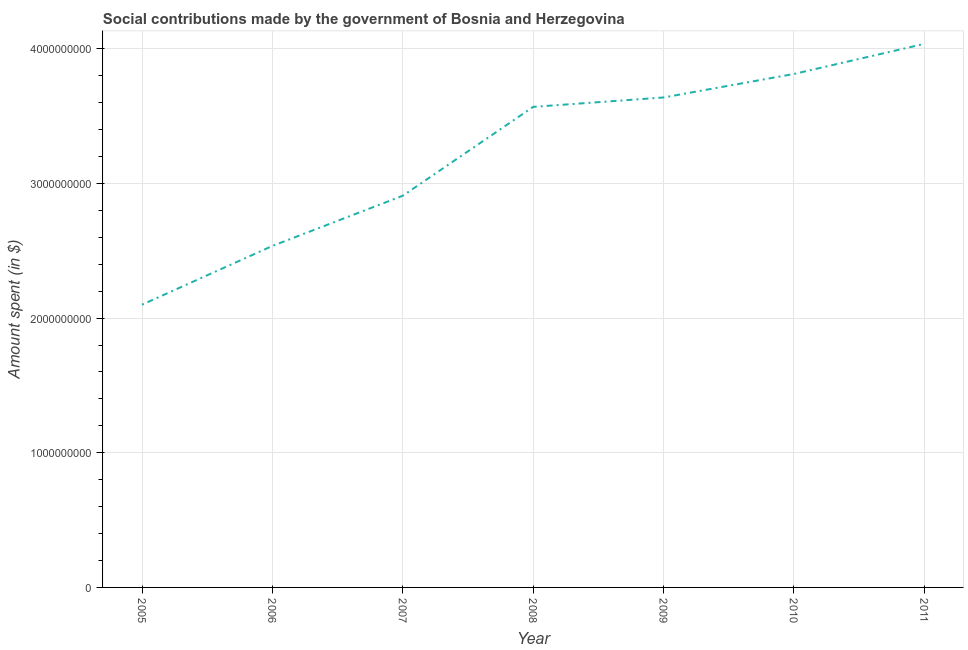What is the amount spent in making social contributions in 2010?
Your answer should be very brief. 3.81e+09. Across all years, what is the maximum amount spent in making social contributions?
Offer a terse response. 4.04e+09. Across all years, what is the minimum amount spent in making social contributions?
Offer a terse response. 2.10e+09. In which year was the amount spent in making social contributions maximum?
Offer a terse response. 2011. In which year was the amount spent in making social contributions minimum?
Ensure brevity in your answer.  2005. What is the sum of the amount spent in making social contributions?
Your response must be concise. 2.26e+1. What is the difference between the amount spent in making social contributions in 2006 and 2009?
Make the answer very short. -1.10e+09. What is the average amount spent in making social contributions per year?
Give a very brief answer. 3.23e+09. What is the median amount spent in making social contributions?
Ensure brevity in your answer.  3.57e+09. Do a majority of the years between 2009 and 2011 (inclusive) have amount spent in making social contributions greater than 400000000 $?
Provide a short and direct response. Yes. What is the ratio of the amount spent in making social contributions in 2006 to that in 2007?
Your answer should be very brief. 0.87. Is the difference between the amount spent in making social contributions in 2005 and 2011 greater than the difference between any two years?
Your response must be concise. Yes. What is the difference between the highest and the second highest amount spent in making social contributions?
Offer a terse response. 2.23e+08. Is the sum of the amount spent in making social contributions in 2007 and 2008 greater than the maximum amount spent in making social contributions across all years?
Give a very brief answer. Yes. What is the difference between the highest and the lowest amount spent in making social contributions?
Offer a very short reply. 1.94e+09. In how many years, is the amount spent in making social contributions greater than the average amount spent in making social contributions taken over all years?
Your answer should be compact. 4. Does the amount spent in making social contributions monotonically increase over the years?
Provide a short and direct response. Yes. How many lines are there?
Your answer should be compact. 1. What is the difference between two consecutive major ticks on the Y-axis?
Provide a short and direct response. 1.00e+09. Does the graph contain any zero values?
Your response must be concise. No. Does the graph contain grids?
Keep it short and to the point. Yes. What is the title of the graph?
Your answer should be compact. Social contributions made by the government of Bosnia and Herzegovina. What is the label or title of the X-axis?
Offer a very short reply. Year. What is the label or title of the Y-axis?
Keep it short and to the point. Amount spent (in $). What is the Amount spent (in $) of 2005?
Your answer should be compact. 2.10e+09. What is the Amount spent (in $) of 2006?
Your response must be concise. 2.54e+09. What is the Amount spent (in $) in 2007?
Give a very brief answer. 2.91e+09. What is the Amount spent (in $) of 2008?
Your answer should be compact. 3.57e+09. What is the Amount spent (in $) of 2009?
Your answer should be very brief. 3.64e+09. What is the Amount spent (in $) in 2010?
Keep it short and to the point. 3.81e+09. What is the Amount spent (in $) in 2011?
Provide a short and direct response. 4.04e+09. What is the difference between the Amount spent (in $) in 2005 and 2006?
Keep it short and to the point. -4.36e+08. What is the difference between the Amount spent (in $) in 2005 and 2007?
Provide a short and direct response. -8.09e+08. What is the difference between the Amount spent (in $) in 2005 and 2008?
Ensure brevity in your answer.  -1.47e+09. What is the difference between the Amount spent (in $) in 2005 and 2009?
Your answer should be very brief. -1.54e+09. What is the difference between the Amount spent (in $) in 2005 and 2010?
Ensure brevity in your answer.  -1.71e+09. What is the difference between the Amount spent (in $) in 2005 and 2011?
Offer a terse response. -1.94e+09. What is the difference between the Amount spent (in $) in 2006 and 2007?
Give a very brief answer. -3.73e+08. What is the difference between the Amount spent (in $) in 2006 and 2008?
Give a very brief answer. -1.03e+09. What is the difference between the Amount spent (in $) in 2006 and 2009?
Ensure brevity in your answer.  -1.10e+09. What is the difference between the Amount spent (in $) in 2006 and 2010?
Ensure brevity in your answer.  -1.28e+09. What is the difference between the Amount spent (in $) in 2006 and 2011?
Your response must be concise. -1.50e+09. What is the difference between the Amount spent (in $) in 2007 and 2008?
Your answer should be very brief. -6.60e+08. What is the difference between the Amount spent (in $) in 2007 and 2009?
Give a very brief answer. -7.30e+08. What is the difference between the Amount spent (in $) in 2007 and 2010?
Ensure brevity in your answer.  -9.04e+08. What is the difference between the Amount spent (in $) in 2007 and 2011?
Make the answer very short. -1.13e+09. What is the difference between the Amount spent (in $) in 2008 and 2009?
Your answer should be very brief. -6.99e+07. What is the difference between the Amount spent (in $) in 2008 and 2010?
Offer a very short reply. -2.44e+08. What is the difference between the Amount spent (in $) in 2008 and 2011?
Your answer should be compact. -4.68e+08. What is the difference between the Amount spent (in $) in 2009 and 2010?
Offer a very short reply. -1.75e+08. What is the difference between the Amount spent (in $) in 2009 and 2011?
Keep it short and to the point. -3.98e+08. What is the difference between the Amount spent (in $) in 2010 and 2011?
Offer a very short reply. -2.23e+08. What is the ratio of the Amount spent (in $) in 2005 to that in 2006?
Offer a very short reply. 0.83. What is the ratio of the Amount spent (in $) in 2005 to that in 2007?
Offer a terse response. 0.72. What is the ratio of the Amount spent (in $) in 2005 to that in 2008?
Offer a terse response. 0.59. What is the ratio of the Amount spent (in $) in 2005 to that in 2009?
Offer a very short reply. 0.58. What is the ratio of the Amount spent (in $) in 2005 to that in 2010?
Ensure brevity in your answer.  0.55. What is the ratio of the Amount spent (in $) in 2005 to that in 2011?
Your response must be concise. 0.52. What is the ratio of the Amount spent (in $) in 2006 to that in 2007?
Give a very brief answer. 0.87. What is the ratio of the Amount spent (in $) in 2006 to that in 2008?
Your answer should be compact. 0.71. What is the ratio of the Amount spent (in $) in 2006 to that in 2009?
Give a very brief answer. 0.7. What is the ratio of the Amount spent (in $) in 2006 to that in 2010?
Your response must be concise. 0.67. What is the ratio of the Amount spent (in $) in 2006 to that in 2011?
Your response must be concise. 0.63. What is the ratio of the Amount spent (in $) in 2007 to that in 2008?
Ensure brevity in your answer.  0.81. What is the ratio of the Amount spent (in $) in 2007 to that in 2009?
Ensure brevity in your answer.  0.8. What is the ratio of the Amount spent (in $) in 2007 to that in 2010?
Give a very brief answer. 0.76. What is the ratio of the Amount spent (in $) in 2007 to that in 2011?
Give a very brief answer. 0.72. What is the ratio of the Amount spent (in $) in 2008 to that in 2010?
Make the answer very short. 0.94. What is the ratio of the Amount spent (in $) in 2008 to that in 2011?
Ensure brevity in your answer.  0.88. What is the ratio of the Amount spent (in $) in 2009 to that in 2010?
Give a very brief answer. 0.95. What is the ratio of the Amount spent (in $) in 2009 to that in 2011?
Offer a very short reply. 0.9. What is the ratio of the Amount spent (in $) in 2010 to that in 2011?
Keep it short and to the point. 0.94. 